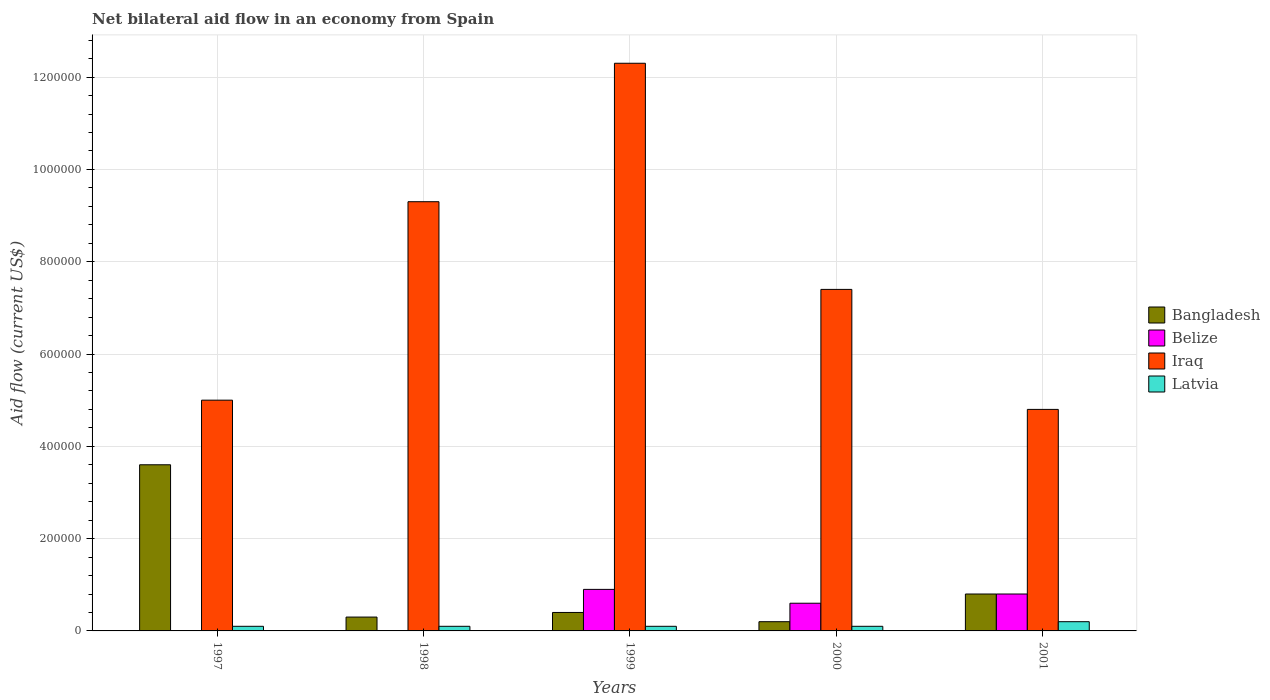How many different coloured bars are there?
Your answer should be very brief. 4. Are the number of bars per tick equal to the number of legend labels?
Ensure brevity in your answer.  No. Are the number of bars on each tick of the X-axis equal?
Your answer should be very brief. No. How many bars are there on the 5th tick from the right?
Offer a very short reply. 3. In how many cases, is the number of bars for a given year not equal to the number of legend labels?
Provide a succinct answer. 2. What is the net bilateral aid flow in Belize in 2000?
Provide a short and direct response. 6.00e+04. In which year was the net bilateral aid flow in Belize maximum?
Your response must be concise. 1999. What is the total net bilateral aid flow in Iraq in the graph?
Your answer should be compact. 3.88e+06. What is the difference between the net bilateral aid flow in Iraq in 1998 and the net bilateral aid flow in Belize in 1999?
Your answer should be compact. 8.40e+05. What is the average net bilateral aid flow in Iraq per year?
Give a very brief answer. 7.76e+05. In the year 1997, what is the difference between the net bilateral aid flow in Latvia and net bilateral aid flow in Bangladesh?
Your response must be concise. -3.50e+05. Is the net bilateral aid flow in Latvia in 1999 less than that in 2001?
Ensure brevity in your answer.  Yes. Is the difference between the net bilateral aid flow in Latvia in 1997 and 1999 greater than the difference between the net bilateral aid flow in Bangladesh in 1997 and 1999?
Provide a succinct answer. No. What is the difference between the highest and the lowest net bilateral aid flow in Latvia?
Your answer should be compact. 10000. In how many years, is the net bilateral aid flow in Bangladesh greater than the average net bilateral aid flow in Bangladesh taken over all years?
Offer a very short reply. 1. How many bars are there?
Keep it short and to the point. 18. Are the values on the major ticks of Y-axis written in scientific E-notation?
Give a very brief answer. No. Does the graph contain any zero values?
Your response must be concise. Yes. Does the graph contain grids?
Provide a succinct answer. Yes. How many legend labels are there?
Keep it short and to the point. 4. What is the title of the graph?
Keep it short and to the point. Net bilateral aid flow in an economy from Spain. What is the label or title of the X-axis?
Give a very brief answer. Years. What is the Aid flow (current US$) in Bangladesh in 1997?
Ensure brevity in your answer.  3.60e+05. What is the Aid flow (current US$) in Belize in 1997?
Make the answer very short. 0. What is the Aid flow (current US$) in Iraq in 1997?
Your response must be concise. 5.00e+05. What is the Aid flow (current US$) of Latvia in 1997?
Ensure brevity in your answer.  10000. What is the Aid flow (current US$) of Bangladesh in 1998?
Your response must be concise. 3.00e+04. What is the Aid flow (current US$) of Iraq in 1998?
Your answer should be very brief. 9.30e+05. What is the Aid flow (current US$) in Bangladesh in 1999?
Give a very brief answer. 4.00e+04. What is the Aid flow (current US$) in Belize in 1999?
Keep it short and to the point. 9.00e+04. What is the Aid flow (current US$) of Iraq in 1999?
Provide a succinct answer. 1.23e+06. What is the Aid flow (current US$) of Latvia in 1999?
Give a very brief answer. 10000. What is the Aid flow (current US$) of Iraq in 2000?
Give a very brief answer. 7.40e+05. What is the Aid flow (current US$) of Iraq in 2001?
Your response must be concise. 4.80e+05. Across all years, what is the maximum Aid flow (current US$) in Bangladesh?
Offer a very short reply. 3.60e+05. Across all years, what is the maximum Aid flow (current US$) of Iraq?
Your response must be concise. 1.23e+06. Across all years, what is the minimum Aid flow (current US$) in Belize?
Make the answer very short. 0. Across all years, what is the minimum Aid flow (current US$) of Iraq?
Ensure brevity in your answer.  4.80e+05. Across all years, what is the minimum Aid flow (current US$) of Latvia?
Ensure brevity in your answer.  10000. What is the total Aid flow (current US$) of Bangladesh in the graph?
Offer a terse response. 5.30e+05. What is the total Aid flow (current US$) of Belize in the graph?
Your answer should be very brief. 2.30e+05. What is the total Aid flow (current US$) in Iraq in the graph?
Make the answer very short. 3.88e+06. What is the difference between the Aid flow (current US$) of Bangladesh in 1997 and that in 1998?
Provide a short and direct response. 3.30e+05. What is the difference between the Aid flow (current US$) of Iraq in 1997 and that in 1998?
Provide a succinct answer. -4.30e+05. What is the difference between the Aid flow (current US$) of Latvia in 1997 and that in 1998?
Keep it short and to the point. 0. What is the difference between the Aid flow (current US$) in Bangladesh in 1997 and that in 1999?
Give a very brief answer. 3.20e+05. What is the difference between the Aid flow (current US$) in Iraq in 1997 and that in 1999?
Give a very brief answer. -7.30e+05. What is the difference between the Aid flow (current US$) in Latvia in 1997 and that in 1999?
Provide a short and direct response. 0. What is the difference between the Aid flow (current US$) of Bangladesh in 1997 and that in 2000?
Give a very brief answer. 3.40e+05. What is the difference between the Aid flow (current US$) of Iraq in 1997 and that in 2000?
Your answer should be very brief. -2.40e+05. What is the difference between the Aid flow (current US$) of Bangladesh in 1997 and that in 2001?
Your answer should be compact. 2.80e+05. What is the difference between the Aid flow (current US$) in Iraq in 1997 and that in 2001?
Your response must be concise. 2.00e+04. What is the difference between the Aid flow (current US$) in Latvia in 1997 and that in 2001?
Your response must be concise. -10000. What is the difference between the Aid flow (current US$) of Bangladesh in 1998 and that in 1999?
Ensure brevity in your answer.  -10000. What is the difference between the Aid flow (current US$) in Iraq in 1998 and that in 1999?
Provide a short and direct response. -3.00e+05. What is the difference between the Aid flow (current US$) of Latvia in 1998 and that in 1999?
Your answer should be very brief. 0. What is the difference between the Aid flow (current US$) of Bangladesh in 1998 and that in 2000?
Keep it short and to the point. 10000. What is the difference between the Aid flow (current US$) of Iraq in 1998 and that in 2000?
Offer a terse response. 1.90e+05. What is the difference between the Aid flow (current US$) of Latvia in 1998 and that in 2000?
Ensure brevity in your answer.  0. What is the difference between the Aid flow (current US$) in Latvia in 1998 and that in 2001?
Your answer should be very brief. -10000. What is the difference between the Aid flow (current US$) of Belize in 1999 and that in 2000?
Your answer should be very brief. 3.00e+04. What is the difference between the Aid flow (current US$) in Iraq in 1999 and that in 2000?
Your response must be concise. 4.90e+05. What is the difference between the Aid flow (current US$) of Belize in 1999 and that in 2001?
Provide a succinct answer. 10000. What is the difference between the Aid flow (current US$) of Iraq in 1999 and that in 2001?
Your answer should be compact. 7.50e+05. What is the difference between the Aid flow (current US$) in Latvia in 1999 and that in 2001?
Give a very brief answer. -10000. What is the difference between the Aid flow (current US$) in Belize in 2000 and that in 2001?
Make the answer very short. -2.00e+04. What is the difference between the Aid flow (current US$) of Iraq in 2000 and that in 2001?
Provide a succinct answer. 2.60e+05. What is the difference between the Aid flow (current US$) of Bangladesh in 1997 and the Aid flow (current US$) of Iraq in 1998?
Your answer should be compact. -5.70e+05. What is the difference between the Aid flow (current US$) in Bangladesh in 1997 and the Aid flow (current US$) in Latvia in 1998?
Provide a succinct answer. 3.50e+05. What is the difference between the Aid flow (current US$) of Iraq in 1997 and the Aid flow (current US$) of Latvia in 1998?
Your answer should be very brief. 4.90e+05. What is the difference between the Aid flow (current US$) of Bangladesh in 1997 and the Aid flow (current US$) of Iraq in 1999?
Your response must be concise. -8.70e+05. What is the difference between the Aid flow (current US$) of Bangladesh in 1997 and the Aid flow (current US$) of Latvia in 1999?
Offer a very short reply. 3.50e+05. What is the difference between the Aid flow (current US$) of Bangladesh in 1997 and the Aid flow (current US$) of Belize in 2000?
Provide a succinct answer. 3.00e+05. What is the difference between the Aid flow (current US$) of Bangladesh in 1997 and the Aid flow (current US$) of Iraq in 2000?
Ensure brevity in your answer.  -3.80e+05. What is the difference between the Aid flow (current US$) in Bangladesh in 1997 and the Aid flow (current US$) in Latvia in 2000?
Offer a very short reply. 3.50e+05. What is the difference between the Aid flow (current US$) of Bangladesh in 1997 and the Aid flow (current US$) of Belize in 2001?
Make the answer very short. 2.80e+05. What is the difference between the Aid flow (current US$) of Bangladesh in 1997 and the Aid flow (current US$) of Latvia in 2001?
Keep it short and to the point. 3.40e+05. What is the difference between the Aid flow (current US$) of Iraq in 1997 and the Aid flow (current US$) of Latvia in 2001?
Offer a terse response. 4.80e+05. What is the difference between the Aid flow (current US$) in Bangladesh in 1998 and the Aid flow (current US$) in Iraq in 1999?
Your answer should be compact. -1.20e+06. What is the difference between the Aid flow (current US$) of Bangladesh in 1998 and the Aid flow (current US$) of Latvia in 1999?
Ensure brevity in your answer.  2.00e+04. What is the difference between the Aid flow (current US$) in Iraq in 1998 and the Aid flow (current US$) in Latvia in 1999?
Ensure brevity in your answer.  9.20e+05. What is the difference between the Aid flow (current US$) in Bangladesh in 1998 and the Aid flow (current US$) in Iraq in 2000?
Offer a terse response. -7.10e+05. What is the difference between the Aid flow (current US$) in Iraq in 1998 and the Aid flow (current US$) in Latvia in 2000?
Offer a terse response. 9.20e+05. What is the difference between the Aid flow (current US$) in Bangladesh in 1998 and the Aid flow (current US$) in Iraq in 2001?
Make the answer very short. -4.50e+05. What is the difference between the Aid flow (current US$) of Iraq in 1998 and the Aid flow (current US$) of Latvia in 2001?
Offer a terse response. 9.10e+05. What is the difference between the Aid flow (current US$) in Bangladesh in 1999 and the Aid flow (current US$) in Iraq in 2000?
Provide a short and direct response. -7.00e+05. What is the difference between the Aid flow (current US$) in Bangladesh in 1999 and the Aid flow (current US$) in Latvia in 2000?
Your answer should be very brief. 3.00e+04. What is the difference between the Aid flow (current US$) of Belize in 1999 and the Aid flow (current US$) of Iraq in 2000?
Make the answer very short. -6.50e+05. What is the difference between the Aid flow (current US$) of Belize in 1999 and the Aid flow (current US$) of Latvia in 2000?
Provide a succinct answer. 8.00e+04. What is the difference between the Aid flow (current US$) in Iraq in 1999 and the Aid flow (current US$) in Latvia in 2000?
Offer a very short reply. 1.22e+06. What is the difference between the Aid flow (current US$) in Bangladesh in 1999 and the Aid flow (current US$) in Belize in 2001?
Your response must be concise. -4.00e+04. What is the difference between the Aid flow (current US$) of Bangladesh in 1999 and the Aid flow (current US$) of Iraq in 2001?
Give a very brief answer. -4.40e+05. What is the difference between the Aid flow (current US$) of Belize in 1999 and the Aid flow (current US$) of Iraq in 2001?
Offer a terse response. -3.90e+05. What is the difference between the Aid flow (current US$) of Belize in 1999 and the Aid flow (current US$) of Latvia in 2001?
Give a very brief answer. 7.00e+04. What is the difference between the Aid flow (current US$) in Iraq in 1999 and the Aid flow (current US$) in Latvia in 2001?
Your answer should be very brief. 1.21e+06. What is the difference between the Aid flow (current US$) in Bangladesh in 2000 and the Aid flow (current US$) in Iraq in 2001?
Make the answer very short. -4.60e+05. What is the difference between the Aid flow (current US$) in Bangladesh in 2000 and the Aid flow (current US$) in Latvia in 2001?
Keep it short and to the point. 0. What is the difference between the Aid flow (current US$) in Belize in 2000 and the Aid flow (current US$) in Iraq in 2001?
Keep it short and to the point. -4.20e+05. What is the difference between the Aid flow (current US$) of Iraq in 2000 and the Aid flow (current US$) of Latvia in 2001?
Keep it short and to the point. 7.20e+05. What is the average Aid flow (current US$) in Bangladesh per year?
Offer a very short reply. 1.06e+05. What is the average Aid flow (current US$) in Belize per year?
Ensure brevity in your answer.  4.60e+04. What is the average Aid flow (current US$) of Iraq per year?
Your answer should be very brief. 7.76e+05. What is the average Aid flow (current US$) of Latvia per year?
Your answer should be very brief. 1.20e+04. In the year 1997, what is the difference between the Aid flow (current US$) of Bangladesh and Aid flow (current US$) of Iraq?
Offer a terse response. -1.40e+05. In the year 1997, what is the difference between the Aid flow (current US$) in Bangladesh and Aid flow (current US$) in Latvia?
Your response must be concise. 3.50e+05. In the year 1998, what is the difference between the Aid flow (current US$) in Bangladesh and Aid flow (current US$) in Iraq?
Give a very brief answer. -9.00e+05. In the year 1998, what is the difference between the Aid flow (current US$) of Bangladesh and Aid flow (current US$) of Latvia?
Ensure brevity in your answer.  2.00e+04. In the year 1998, what is the difference between the Aid flow (current US$) in Iraq and Aid flow (current US$) in Latvia?
Your answer should be compact. 9.20e+05. In the year 1999, what is the difference between the Aid flow (current US$) in Bangladesh and Aid flow (current US$) in Iraq?
Ensure brevity in your answer.  -1.19e+06. In the year 1999, what is the difference between the Aid flow (current US$) of Bangladesh and Aid flow (current US$) of Latvia?
Your answer should be compact. 3.00e+04. In the year 1999, what is the difference between the Aid flow (current US$) in Belize and Aid flow (current US$) in Iraq?
Offer a very short reply. -1.14e+06. In the year 1999, what is the difference between the Aid flow (current US$) in Iraq and Aid flow (current US$) in Latvia?
Make the answer very short. 1.22e+06. In the year 2000, what is the difference between the Aid flow (current US$) in Bangladesh and Aid flow (current US$) in Belize?
Provide a succinct answer. -4.00e+04. In the year 2000, what is the difference between the Aid flow (current US$) of Bangladesh and Aid flow (current US$) of Iraq?
Give a very brief answer. -7.20e+05. In the year 2000, what is the difference between the Aid flow (current US$) in Bangladesh and Aid flow (current US$) in Latvia?
Provide a succinct answer. 10000. In the year 2000, what is the difference between the Aid flow (current US$) of Belize and Aid flow (current US$) of Iraq?
Provide a succinct answer. -6.80e+05. In the year 2000, what is the difference between the Aid flow (current US$) in Iraq and Aid flow (current US$) in Latvia?
Offer a very short reply. 7.30e+05. In the year 2001, what is the difference between the Aid flow (current US$) in Bangladesh and Aid flow (current US$) in Belize?
Keep it short and to the point. 0. In the year 2001, what is the difference between the Aid flow (current US$) in Bangladesh and Aid flow (current US$) in Iraq?
Give a very brief answer. -4.00e+05. In the year 2001, what is the difference between the Aid flow (current US$) of Bangladesh and Aid flow (current US$) of Latvia?
Provide a succinct answer. 6.00e+04. In the year 2001, what is the difference between the Aid flow (current US$) of Belize and Aid flow (current US$) of Iraq?
Make the answer very short. -4.00e+05. In the year 2001, what is the difference between the Aid flow (current US$) in Belize and Aid flow (current US$) in Latvia?
Ensure brevity in your answer.  6.00e+04. In the year 2001, what is the difference between the Aid flow (current US$) in Iraq and Aid flow (current US$) in Latvia?
Give a very brief answer. 4.60e+05. What is the ratio of the Aid flow (current US$) in Bangladesh in 1997 to that in 1998?
Give a very brief answer. 12. What is the ratio of the Aid flow (current US$) in Iraq in 1997 to that in 1998?
Give a very brief answer. 0.54. What is the ratio of the Aid flow (current US$) in Bangladesh in 1997 to that in 1999?
Make the answer very short. 9. What is the ratio of the Aid flow (current US$) of Iraq in 1997 to that in 1999?
Give a very brief answer. 0.41. What is the ratio of the Aid flow (current US$) of Iraq in 1997 to that in 2000?
Provide a succinct answer. 0.68. What is the ratio of the Aid flow (current US$) in Bangladesh in 1997 to that in 2001?
Offer a very short reply. 4.5. What is the ratio of the Aid flow (current US$) of Iraq in 1997 to that in 2001?
Provide a succinct answer. 1.04. What is the ratio of the Aid flow (current US$) of Iraq in 1998 to that in 1999?
Make the answer very short. 0.76. What is the ratio of the Aid flow (current US$) in Bangladesh in 1998 to that in 2000?
Offer a very short reply. 1.5. What is the ratio of the Aid flow (current US$) in Iraq in 1998 to that in 2000?
Make the answer very short. 1.26. What is the ratio of the Aid flow (current US$) in Bangladesh in 1998 to that in 2001?
Ensure brevity in your answer.  0.38. What is the ratio of the Aid flow (current US$) in Iraq in 1998 to that in 2001?
Offer a terse response. 1.94. What is the ratio of the Aid flow (current US$) in Belize in 1999 to that in 2000?
Your response must be concise. 1.5. What is the ratio of the Aid flow (current US$) of Iraq in 1999 to that in 2000?
Keep it short and to the point. 1.66. What is the ratio of the Aid flow (current US$) in Iraq in 1999 to that in 2001?
Offer a very short reply. 2.56. What is the ratio of the Aid flow (current US$) of Bangladesh in 2000 to that in 2001?
Keep it short and to the point. 0.25. What is the ratio of the Aid flow (current US$) in Belize in 2000 to that in 2001?
Offer a very short reply. 0.75. What is the ratio of the Aid flow (current US$) in Iraq in 2000 to that in 2001?
Provide a succinct answer. 1.54. What is the difference between the highest and the second highest Aid flow (current US$) in Bangladesh?
Provide a short and direct response. 2.80e+05. What is the difference between the highest and the second highest Aid flow (current US$) of Belize?
Provide a succinct answer. 10000. What is the difference between the highest and the second highest Aid flow (current US$) in Iraq?
Offer a terse response. 3.00e+05. What is the difference between the highest and the lowest Aid flow (current US$) in Bangladesh?
Make the answer very short. 3.40e+05. What is the difference between the highest and the lowest Aid flow (current US$) of Belize?
Provide a succinct answer. 9.00e+04. What is the difference between the highest and the lowest Aid flow (current US$) of Iraq?
Your response must be concise. 7.50e+05. 